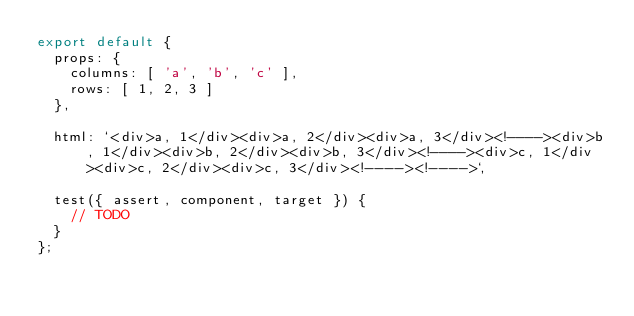<code> <loc_0><loc_0><loc_500><loc_500><_JavaScript_>export default {
	props: {
		columns: [ 'a', 'b', 'c' ],
		rows: [ 1, 2, 3 ]
	},

	html: `<div>a, 1</div><div>a, 2</div><div>a, 3</div><!----><div>b, 1</div><div>b, 2</div><div>b, 3</div><!----><div>c, 1</div><div>c, 2</div><div>c, 3</div><!----><!---->`,

	test({ assert, component, target }) {
		// TODO
	}
};
</code> 